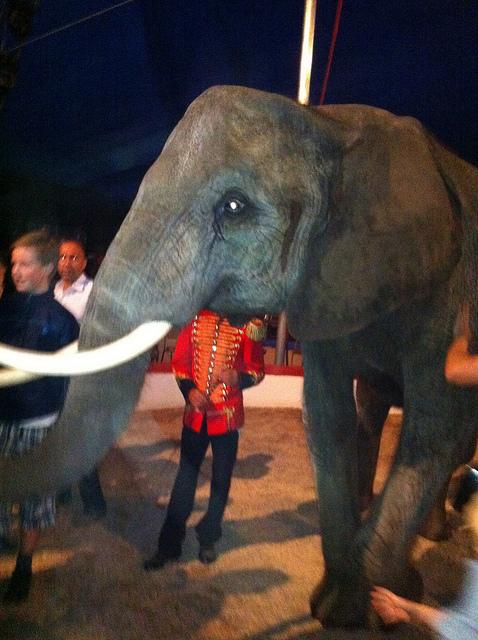What event might this be? circus 